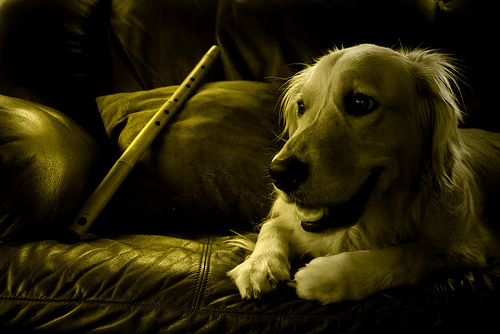<image>
Is there a cat under the banjo? No. The cat is not positioned under the banjo. The vertical relationship between these objects is different. 